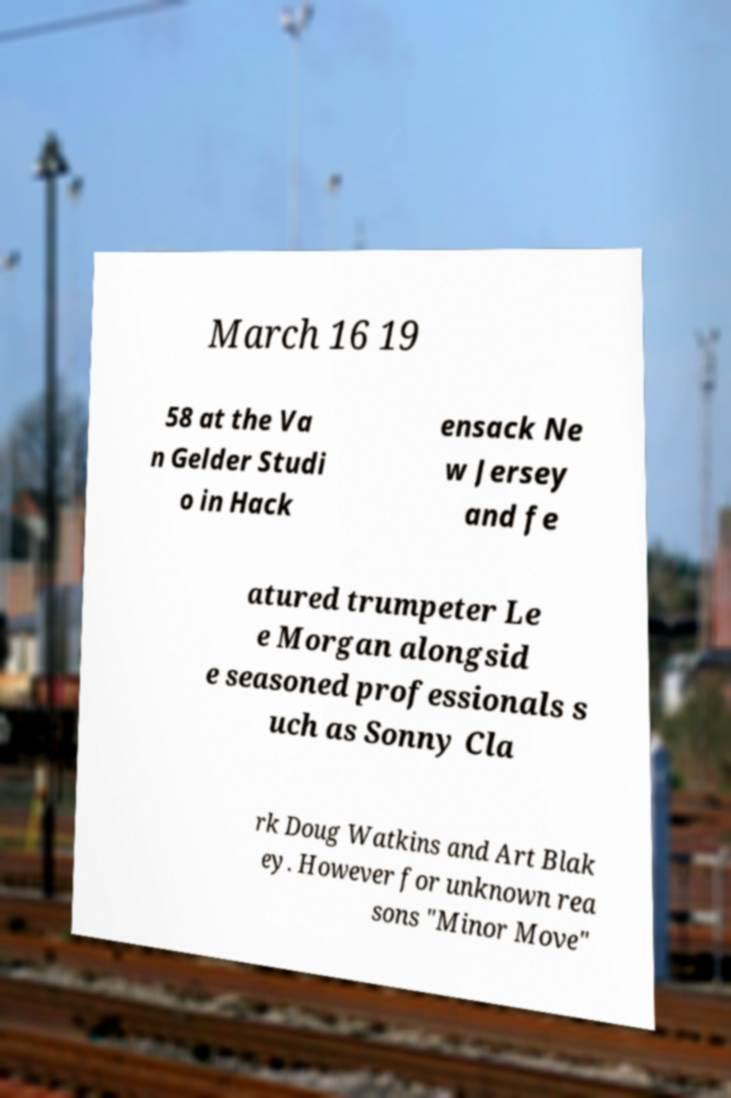There's text embedded in this image that I need extracted. Can you transcribe it verbatim? March 16 19 58 at the Va n Gelder Studi o in Hack ensack Ne w Jersey and fe atured trumpeter Le e Morgan alongsid e seasoned professionals s uch as Sonny Cla rk Doug Watkins and Art Blak ey. However for unknown rea sons "Minor Move" 